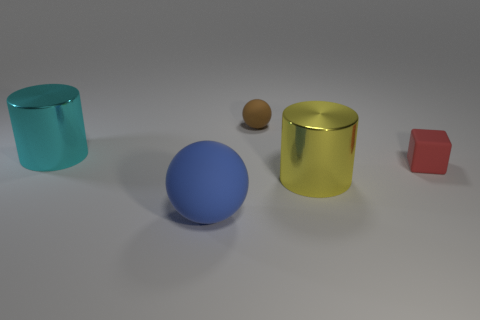Add 3 big yellow cylinders. How many objects exist? 8 Subtract 1 balls. How many balls are left? 1 Subtract all brown blocks. Subtract all red cylinders. How many blocks are left? 1 Subtract all cyan cylinders. How many red balls are left? 0 Subtract all small cyan blocks. Subtract all large metallic things. How many objects are left? 3 Add 1 small rubber cubes. How many small rubber cubes are left? 2 Add 2 red cubes. How many red cubes exist? 3 Subtract 0 green cubes. How many objects are left? 5 Subtract all blocks. How many objects are left? 4 